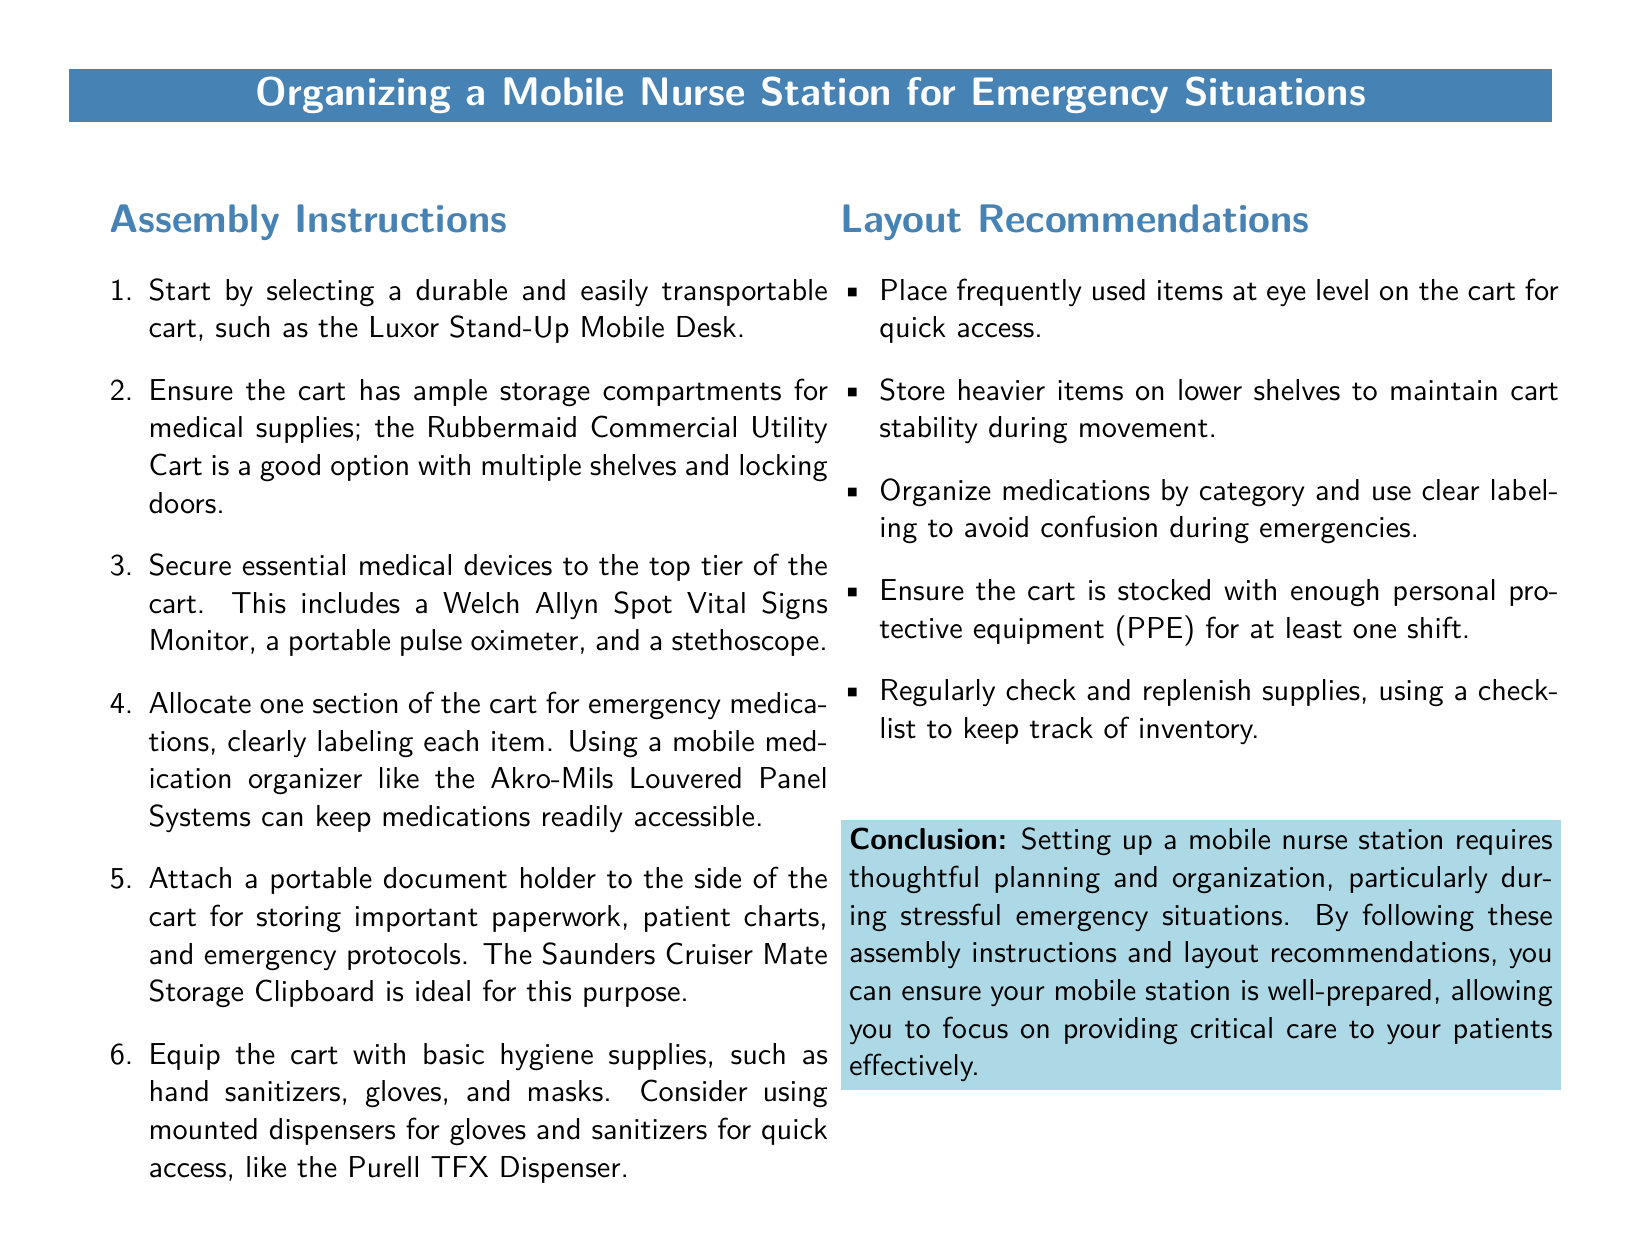What cart is recommended for transport? The document suggests the Luxor Stand-Up Mobile Desk as a durable and easily transportable cart.
Answer: Luxor Stand-Up Mobile Desk What item should be secured to the top tier of the cart? Essential medical devices such as a Welch Allyn Spot Vital Signs Monitor need to be secured to the top tier.
Answer: Welch Allyn Spot Vital Signs Monitor Which system is suggested for organizing medications? The document recommends using the Akro-Mils Louvered Panel Systems for mobile medication organization.
Answer: Akro-Mils Louvered Panel Systems How should frequently used items be stored on the cart? The recommendations specify placing frequently used items at eye level on the cart for quick access.
Answer: Eye level How often should supplies be checked and replenished? Regular checks are recommended to maintain inventory, but the document does not specify a frequency.
Answer: Regularly What is a key characteristic of items stored on the lower shelves? Heavier items should be stored on lower shelves to maintain stability during movement.
Answer: Stability What is the conclusion about setting up a mobile nurse station? The conclusion emphasizes the importance of thoughtful planning and organization especially during emergencies.
Answer: Thoughtful planning and organization Which document holder is suggested for storing important papers? The Saunders Cruiser Mate Storage Clipboard is recommended for important paperwork and emergency protocols.
Answer: Saunders Cruiser Mate Storage Clipboard How many shifts should the PPE be stocked for? The document states that the cart should be stocked with enough PPE for at least one shift.
Answer: One shift 